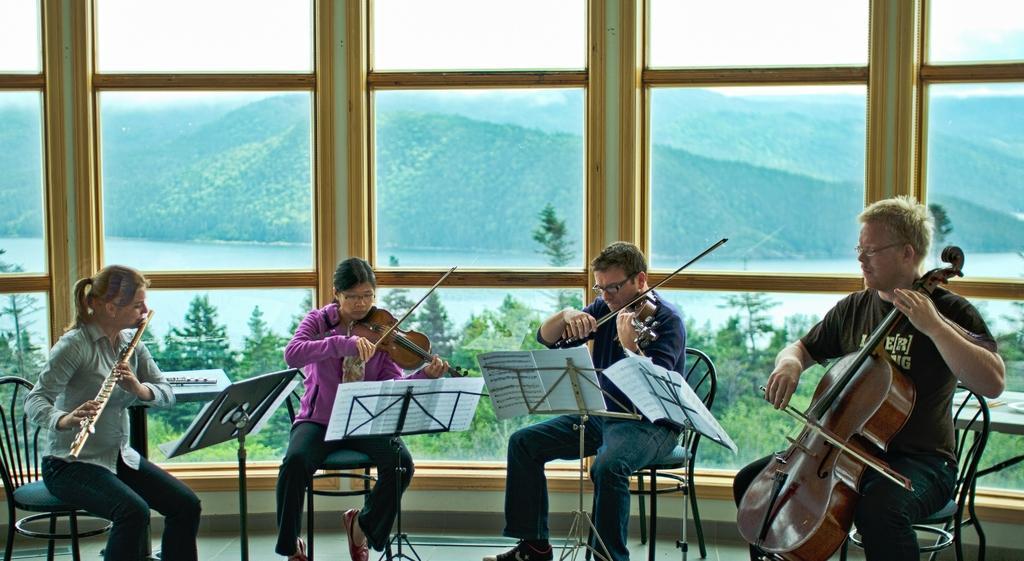Could you give a brief overview of what you see in this image? In the image we can see four persons sitting on the chair and holding musical instruments. And back we can see hill,glass,water,trees,grass and plant. 